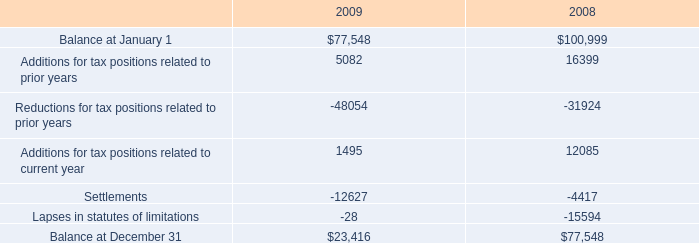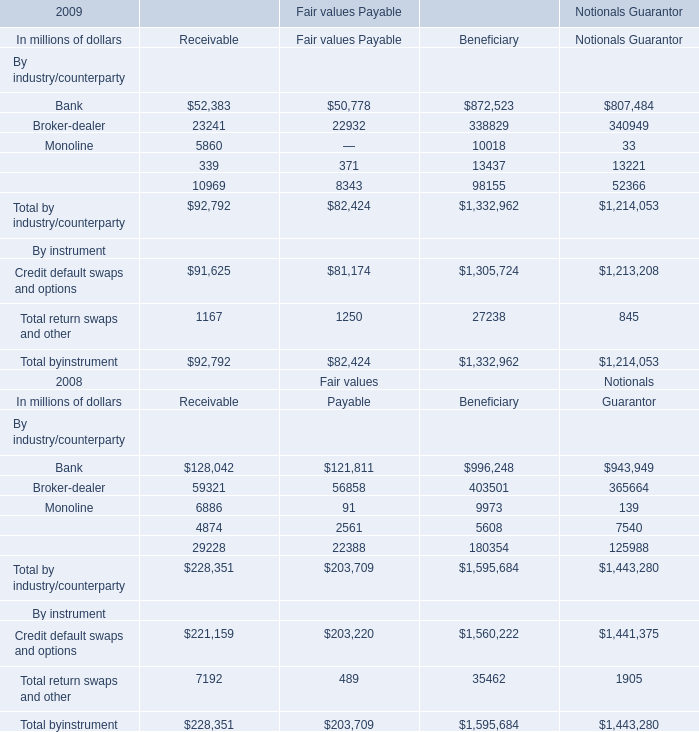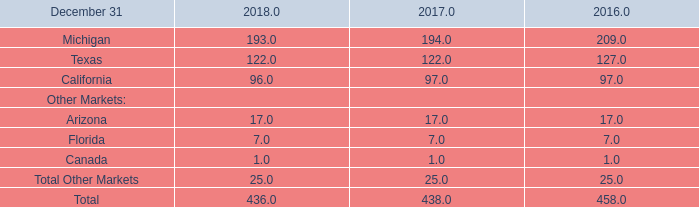Does the value of By instrument:Credit default swaps and options in 2009 greater than that in 2008 for Receivable? 
Answer: no. 